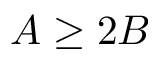Convert formula to latex. <formula><loc_0><loc_0><loc_500><loc_500>A \geq 2 B</formula> 